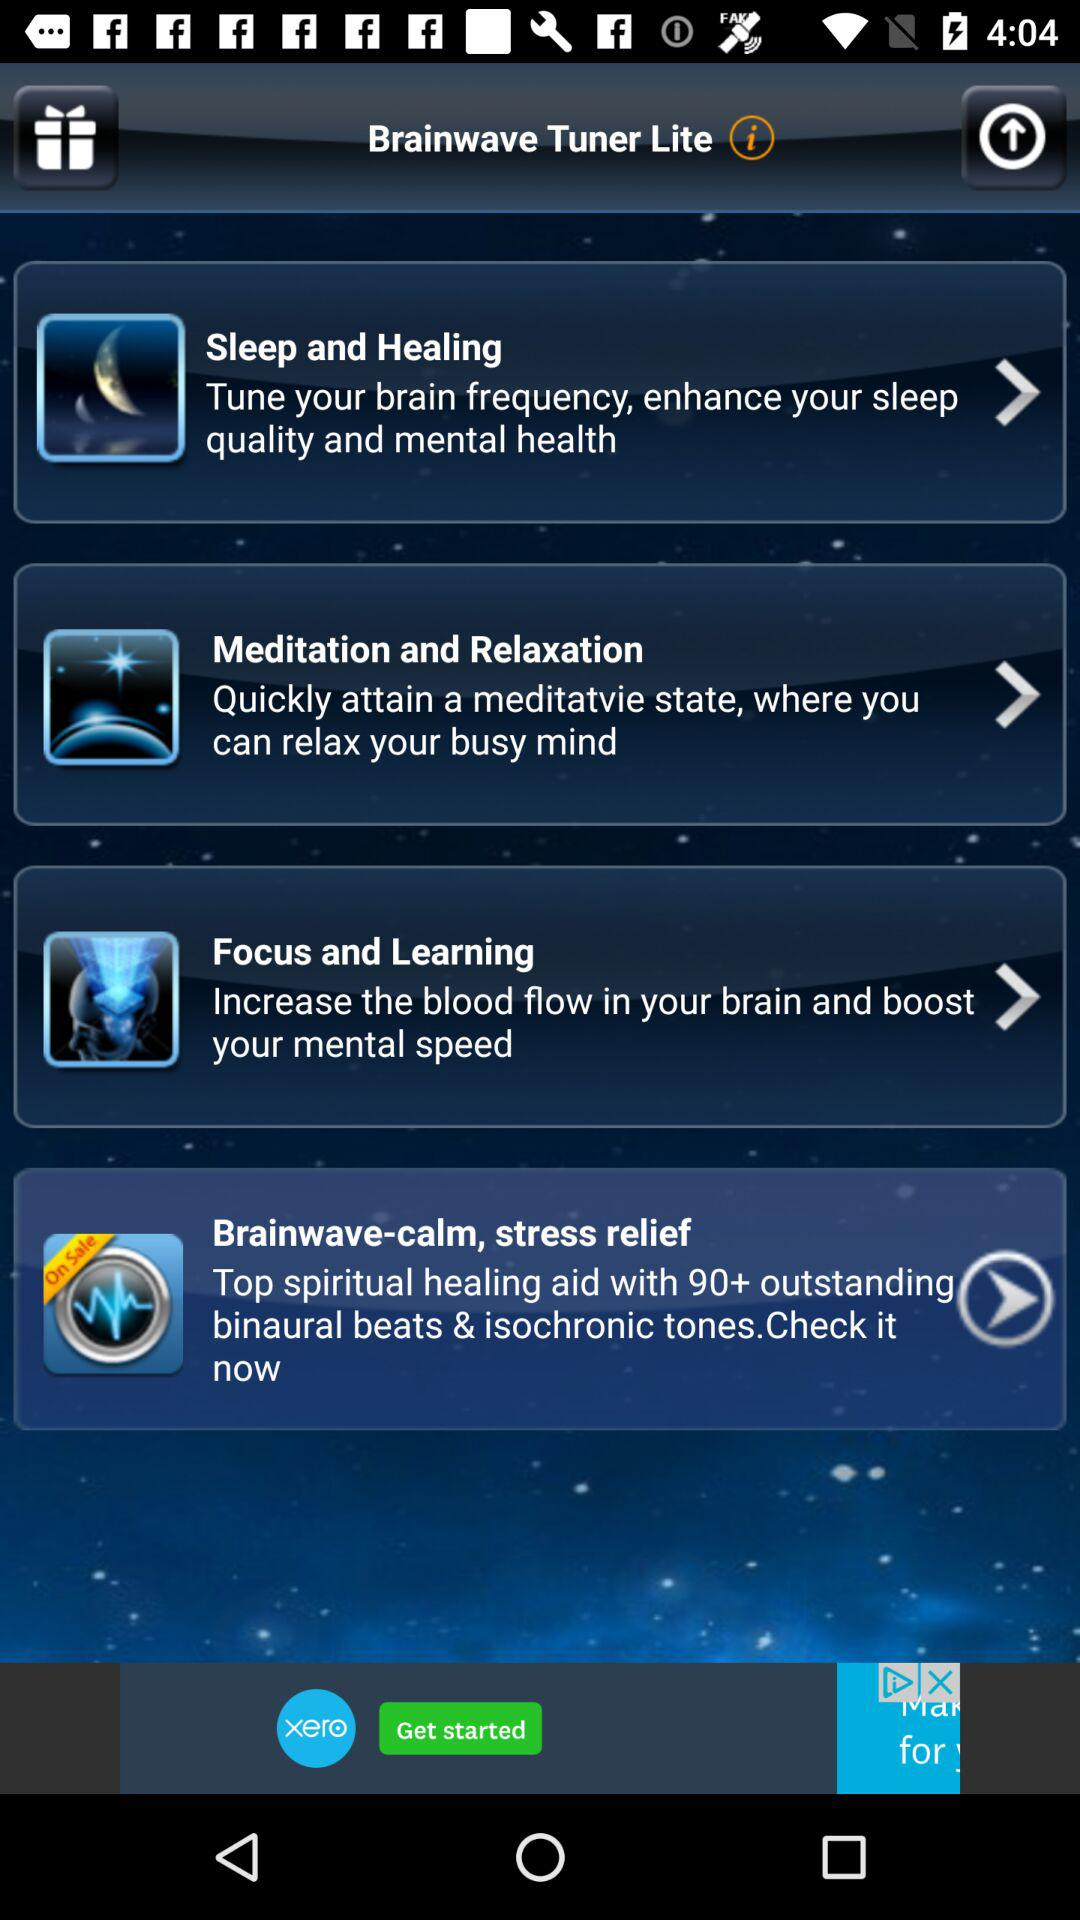What is the application name? The application name is "Brainwave Tuner Lite". 